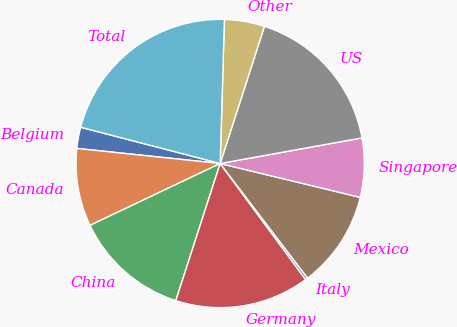Convert chart to OTSL. <chart><loc_0><loc_0><loc_500><loc_500><pie_chart><fcel>Belgium<fcel>Canada<fcel>China<fcel>Germany<fcel>Italy<fcel>Mexico<fcel>Singapore<fcel>US<fcel>Other<fcel>Total<nl><fcel>2.38%<fcel>8.73%<fcel>12.96%<fcel>15.08%<fcel>0.27%<fcel>10.85%<fcel>6.62%<fcel>17.19%<fcel>4.5%<fcel>21.42%<nl></chart> 